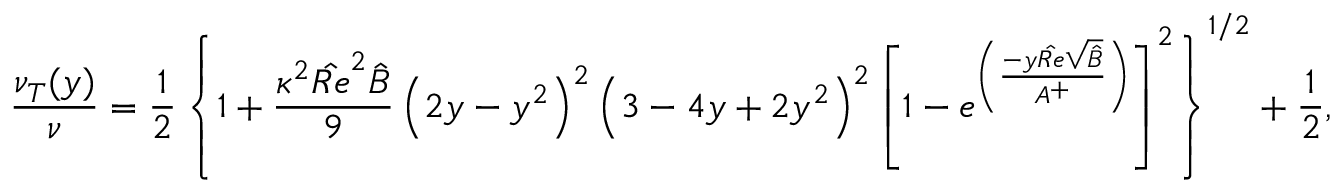<formula> <loc_0><loc_0><loc_500><loc_500>\frac { \nu _ { T } ( y ) } { \nu } = \frac { 1 } { 2 } \left \{ 1 + \frac { \kappa ^ { 2 } { \hat { R e } } ^ { 2 } \hat { B } } { 9 } \left ( 2 y - y ^ { 2 } \right ) ^ { 2 } \left ( 3 - 4 y + 2 y ^ { 2 } \right ) ^ { 2 } \left [ 1 - e ^ { \left ( \frac { - y \hat { R e } \sqrt { \hat { B } } } { A ^ { + } } \right ) } \right ] ^ { 2 } \right \} ^ { 1 / 2 } + \frac { 1 } { 2 } ,</formula> 